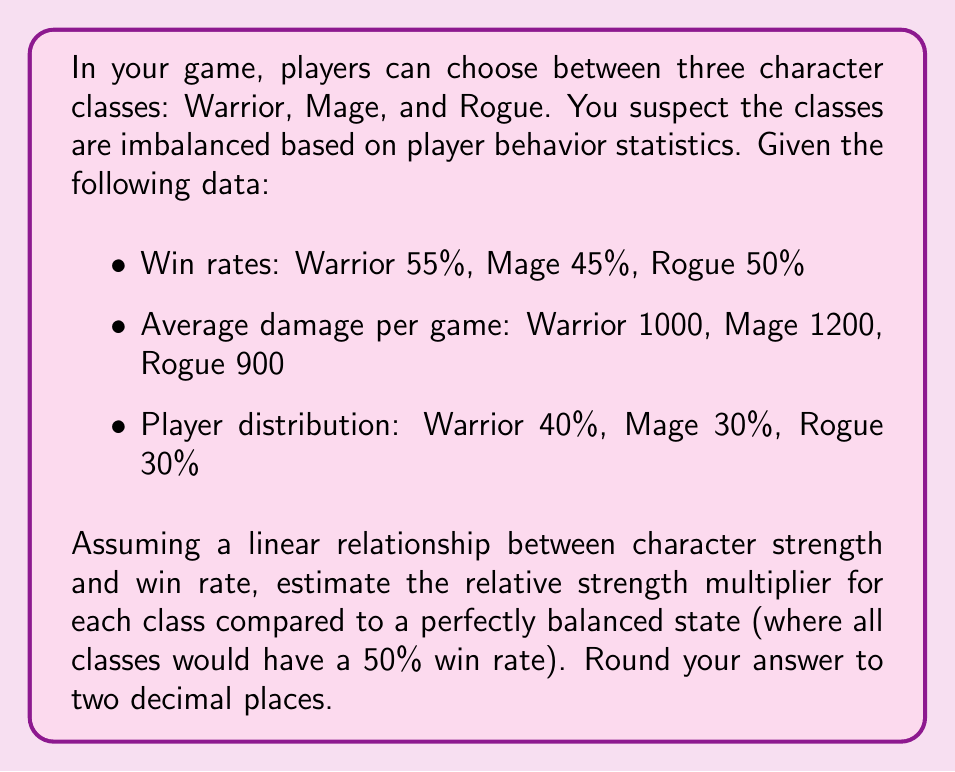Teach me how to tackle this problem. To solve this inverse problem and infer the original game balance parameters, we'll follow these steps:

1) First, we need to establish a baseline for a perfectly balanced state. In this case, it would be a 50% win rate for all classes.

2) We can calculate the deviation from this balanced state for each class:
   Warrior: 55% - 50% = +5%
   Mage: 45% - 50% = -5%
   Rogue: 50% - 50% = 0%

3) Assuming a linear relationship between strength and win rate, we can use these deviations to estimate relative strength multipliers. Let's set the balanced state strength as 1.00.

4) To calculate the strength multiplier, we use the formula:
   $\text{Strength Multiplier} = 1 + \frac{\text{Win Rate Deviation}}{100}$

5) For each class:
   Warrior: $1 + \frac{5}{100} = 1.05$
   Mage: $1 + \frac{-5}{100} = 0.95$
   Rogue: $1 + \frac{0}{100} = 1.00$

These multipliers represent the relative strength of each class compared to a perfectly balanced state.
Answer: Warrior: 1.05, Mage: 0.95, Rogue: 1.00 